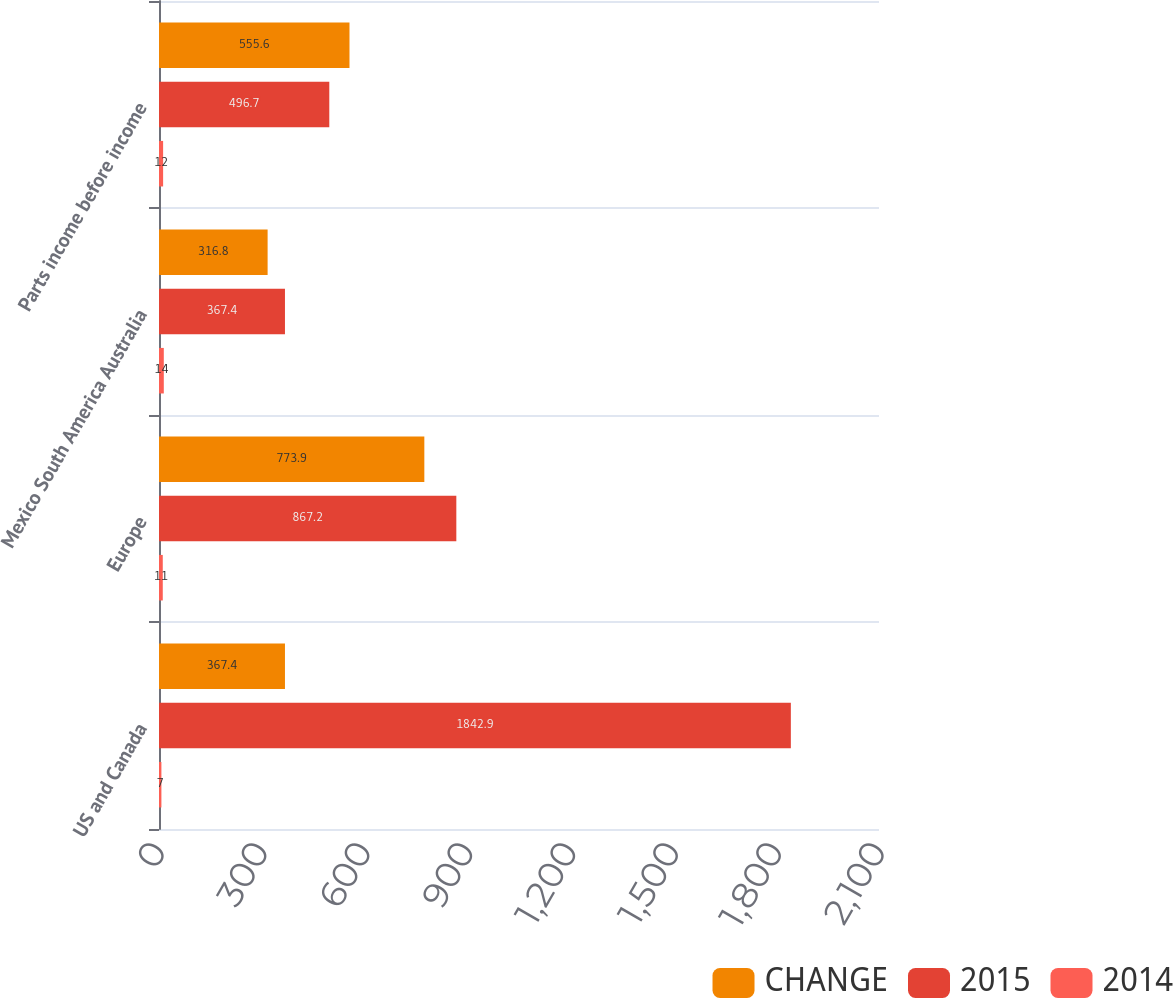Convert chart to OTSL. <chart><loc_0><loc_0><loc_500><loc_500><stacked_bar_chart><ecel><fcel>US and Canada<fcel>Europe<fcel>Mexico South America Australia<fcel>Parts income before income<nl><fcel>CHANGE<fcel>367.4<fcel>773.9<fcel>316.8<fcel>555.6<nl><fcel>2015<fcel>1842.9<fcel>867.2<fcel>367.4<fcel>496.7<nl><fcel>2014<fcel>7<fcel>11<fcel>14<fcel>12<nl></chart> 